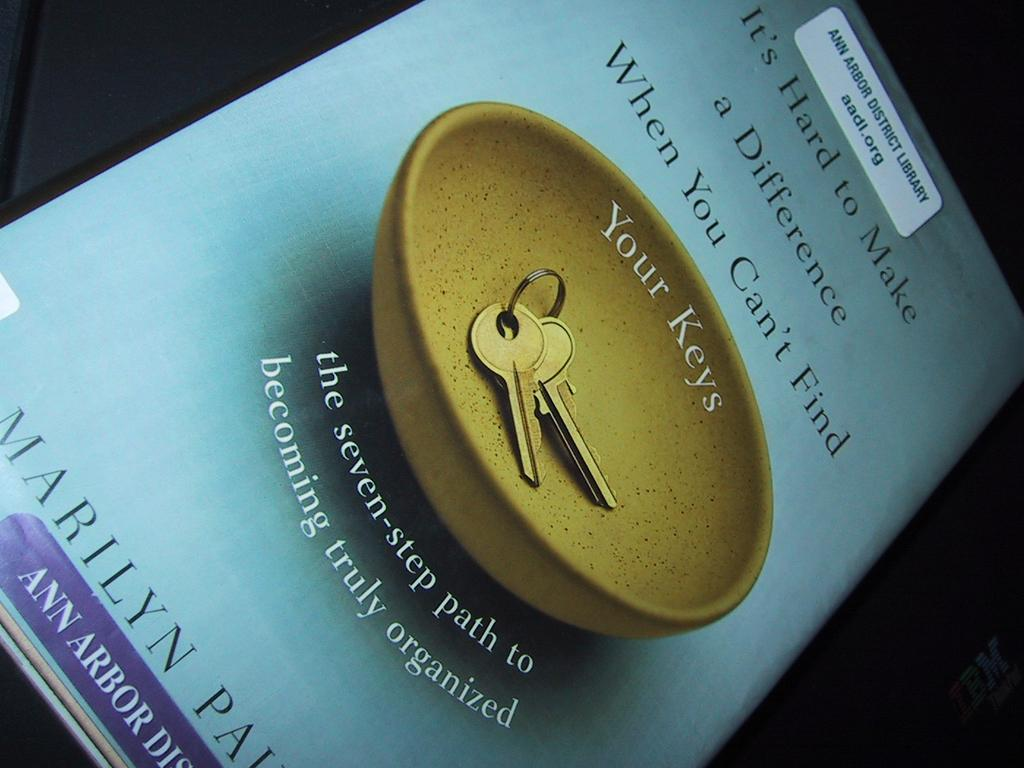<image>
Relay a brief, clear account of the picture shown. A book titled "It's Hard to Make a Difference When You Can't Find Your Keys", a guide for getting organized. 